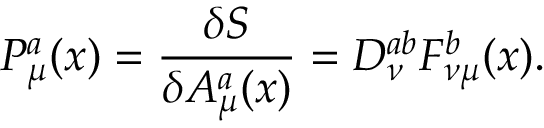Convert formula to latex. <formula><loc_0><loc_0><loc_500><loc_500>P _ { \mu } ^ { a } ( x ) = \frac { \delta { S } } { \delta { A _ { \mu } ^ { a } ( x ) } } = D _ { \nu } ^ { a b } F _ { \nu \mu } ^ { b } ( x ) .</formula> 